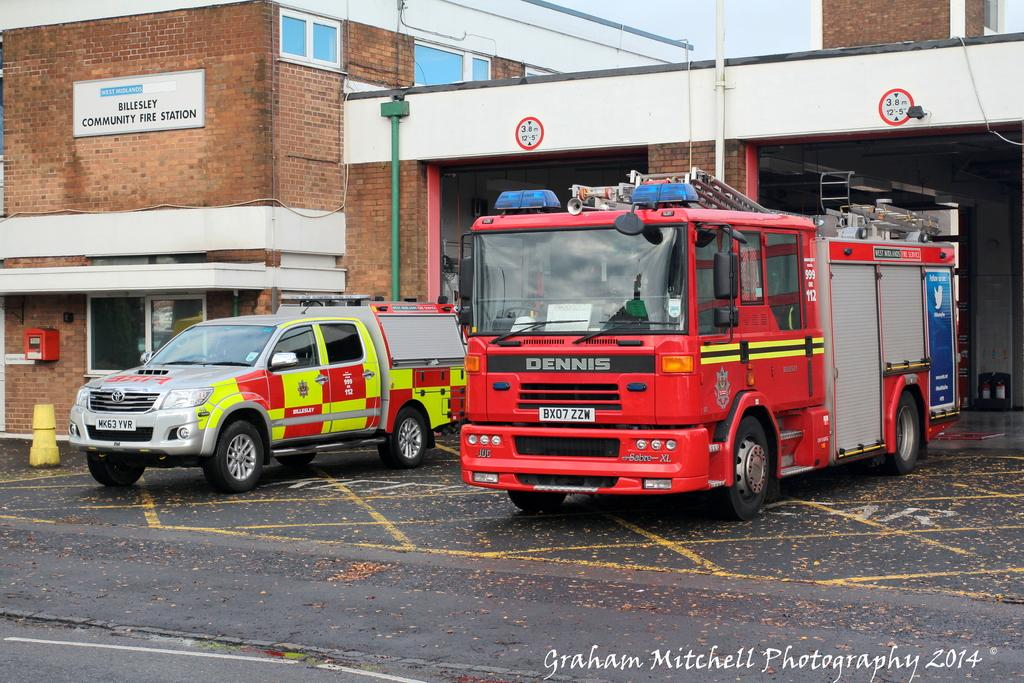What can be seen on the road in the image? There are vehicles on the road in the image. What else is visible in the image besides the vehicles? There is some text, a traffic cone, poles, buildings, and boards visible in the image. What is the background of the image composed of? The background of the image includes a traffic cone, poles, buildings, and boards. What is visible at the top of the image? The sky is visible at the top of the image. What is the tendency of the nose in the image? There is no nose present in the image, so it is not possible to determine its tendency. 